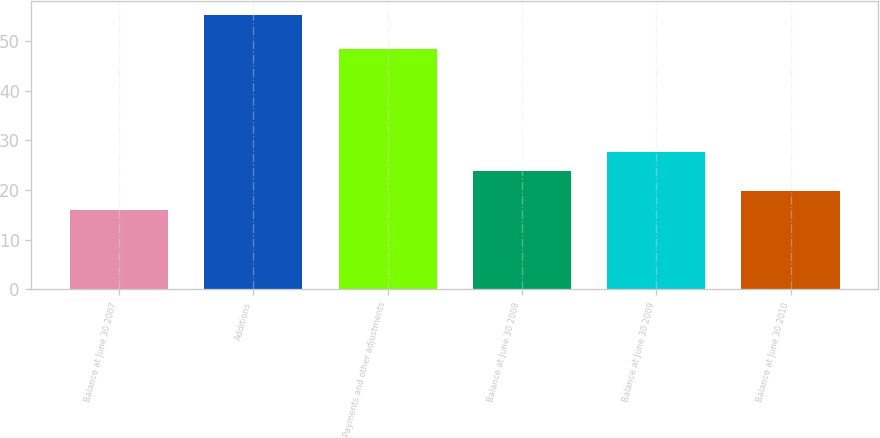Convert chart. <chart><loc_0><loc_0><loc_500><loc_500><bar_chart><fcel>Balance at June 30 2007<fcel>Additions<fcel>Payments and other adjustments<fcel>Balance at June 30 2008<fcel>Balance at June 30 2009<fcel>Balance at June 30 2010<nl><fcel>15.9<fcel>55.3<fcel>48.3<fcel>23.78<fcel>27.72<fcel>19.84<nl></chart> 